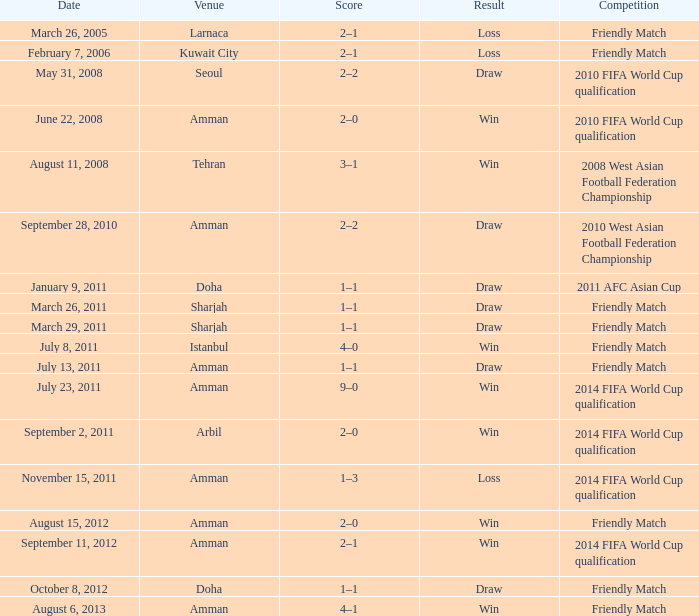During the loss on march 26, 2005, what was the venue where the match was played? Larnaca. 